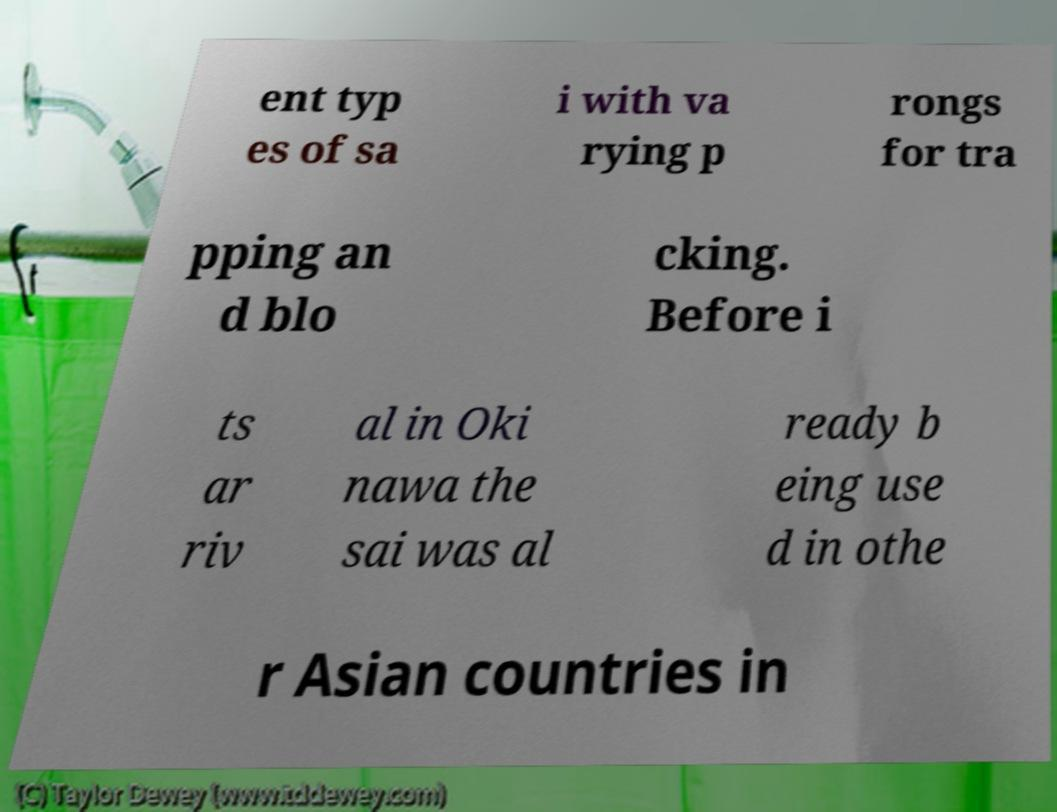Could you extract and type out the text from this image? ent typ es of sa i with va rying p rongs for tra pping an d blo cking. Before i ts ar riv al in Oki nawa the sai was al ready b eing use d in othe r Asian countries in 